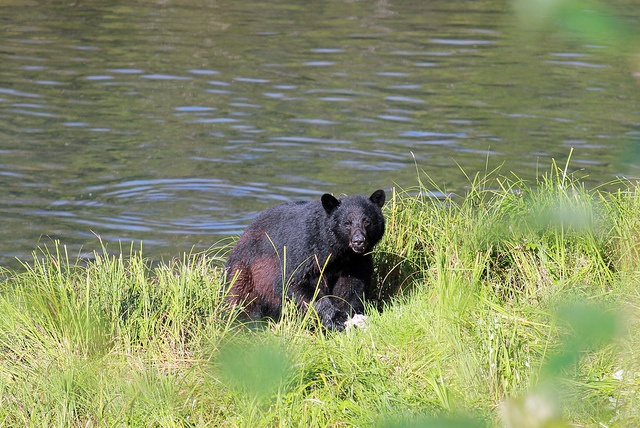Describe the objects in this image and their specific colors. I can see a bear in olive, black, and gray tones in this image. 